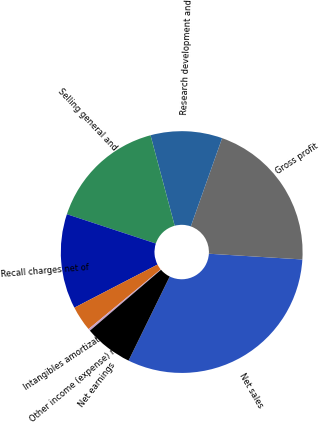Convert chart. <chart><loc_0><loc_0><loc_500><loc_500><pie_chart><fcel>Net sales<fcel>Gross profit<fcel>Research development and<fcel>Selling general and<fcel>Recall charges net of<fcel>Intangibles amortization<fcel>Other income (expense) net<fcel>Net earnings<nl><fcel>31.27%<fcel>20.55%<fcel>9.58%<fcel>15.78%<fcel>12.68%<fcel>3.38%<fcel>0.28%<fcel>6.48%<nl></chart> 